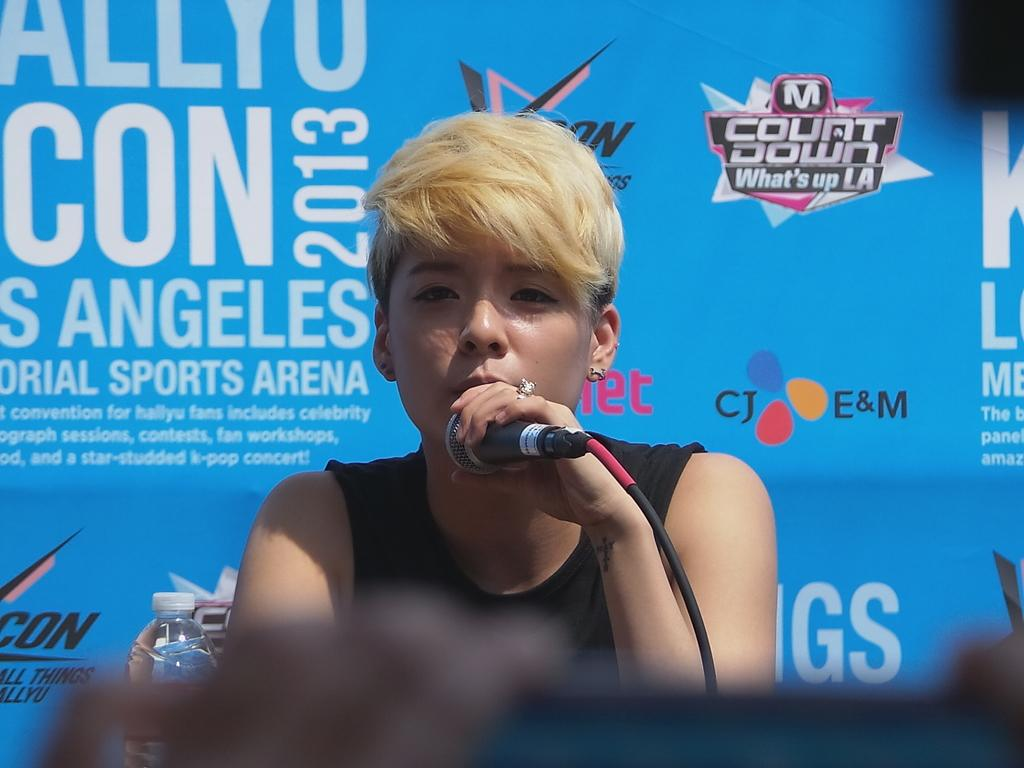What is present in the image that is used for displaying information or messages? There is a banner in the image. What is the woman in the image doing? The woman is holding a mic in the image. What type of cap is the woman wearing in the image? There is no cap present in the image; the woman is not wearing one. What is the woman cooking in the oven in the image? There is no oven present in the image, and therefore no cooking activity can be observed. 